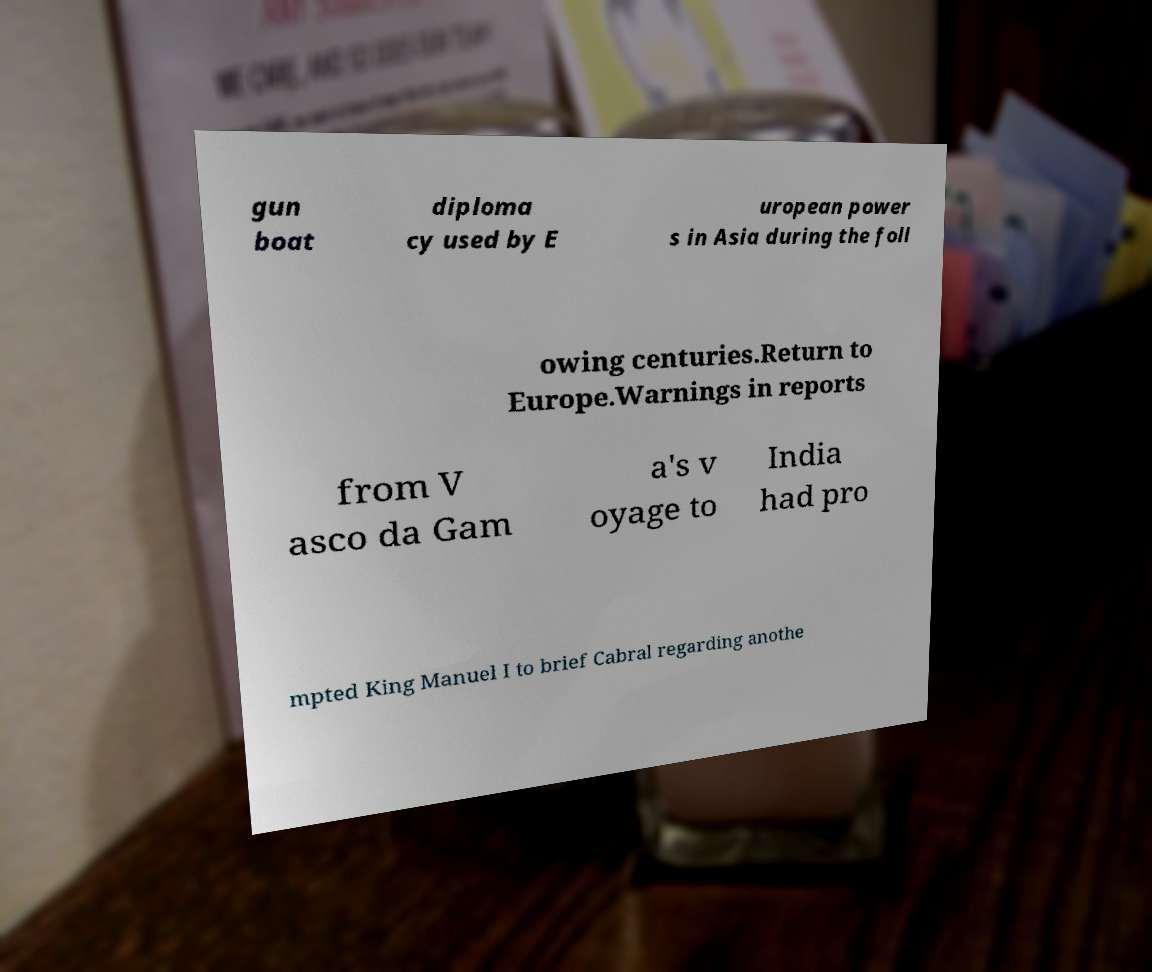There's text embedded in this image that I need extracted. Can you transcribe it verbatim? gun boat diploma cy used by E uropean power s in Asia during the foll owing centuries.Return to Europe.Warnings in reports from V asco da Gam a's v oyage to India had pro mpted King Manuel I to brief Cabral regarding anothe 